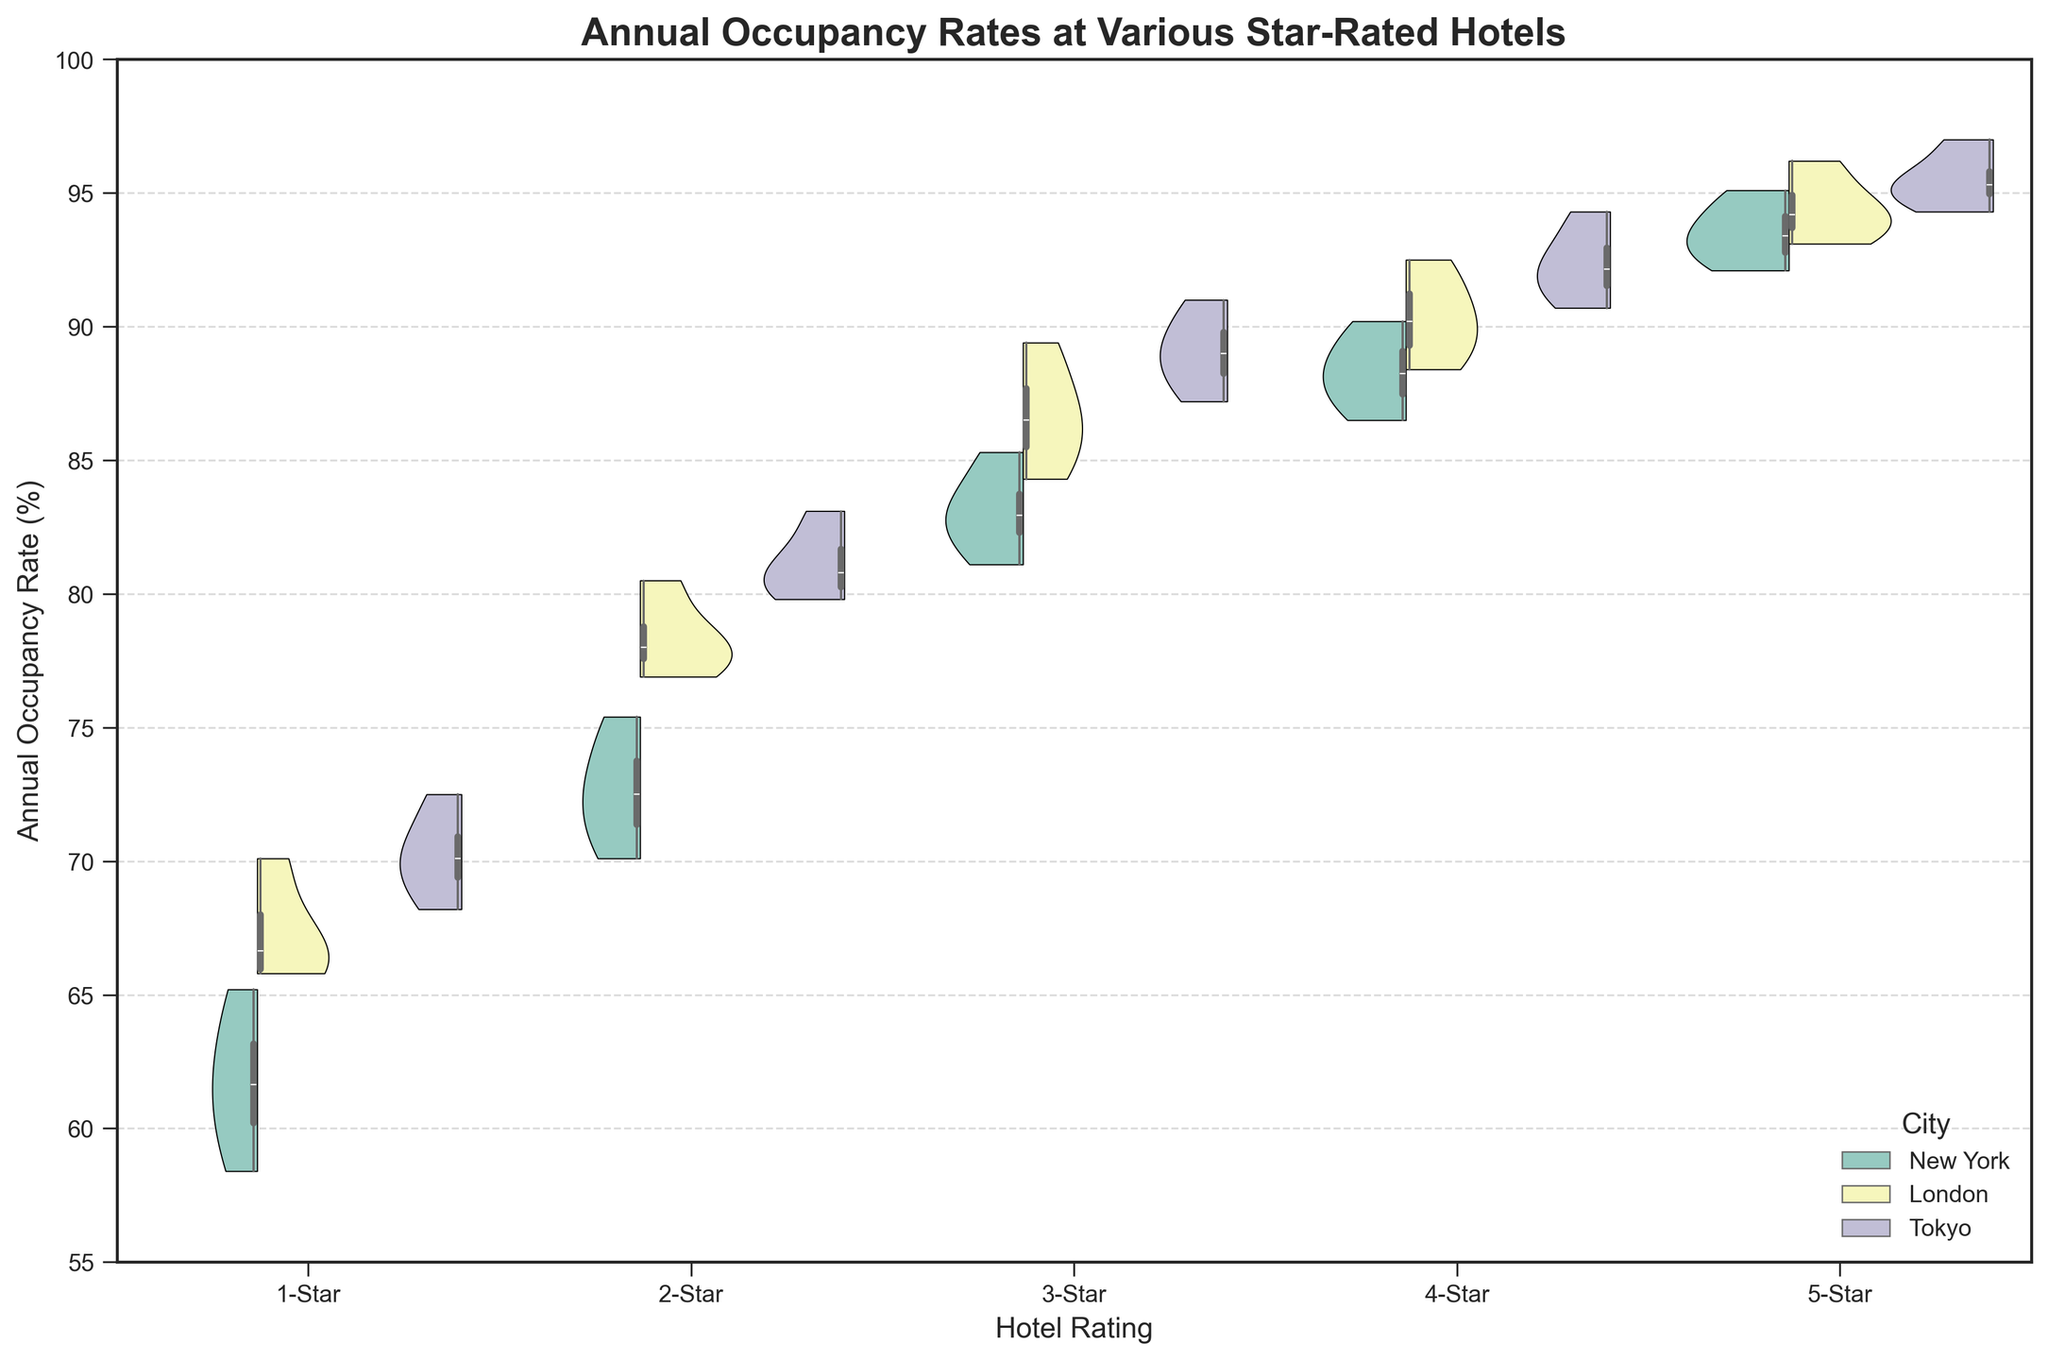What's the title of the figure? The title is displayed at the top of the figure and provides a summary of the visualized data. Looking at the figure, the title is "Annual Occupancy Rates at Various Star-Rated Hotels."
Answer: Annual Occupancy Rates at Various Star-Rated Hotels Which city has the highest median occupancy rate for 3-Star hotels? To determine this, examine the inner box plots within the violin plots for 3-Star hotels and identify which city's box plot has the highest median line. The city with the highest median occupancy rate for 3-Star hotels is Tokyo.
Answer: Tokyo Are the occupancy rates more varied in 1-Star hotels or 5-Star hotels? To assess variability, look at the width and shape of the violin plots. Wider and more spread out plots indicate greater variability. The 1-Star hotels show more spread in occupancy rates compared to 5-Star hotels.
Answer: 1-Star hotels What is the lowest observed occupancy rate for hotels in New York? Identify the smallest point in the New York box plots across all hotel ratings. The lowest point for New York is in the 1-Star category, around 58.4%.
Answer: 58.4% Do Tokyo's 5-Star hotels have a higher median occupancy rate than London's 5-Star hotels? Compare the median lines of the box plots for Tokyo and London in the 5-Star category. Tokyo's median line is higher than London's, indicating a higher median occupancy rate.
Answer: Yes How do the median occupancy rates for 4-Star hotels compare between New York and London? Examine the median lines of the box plots for New York and London in the 4-Star category. London's median is higher than New York’s.
Answer: London's is higher Which star rating shows the largest difference in median occupancy rates between New York and Tokyo? Compare the median lines of the box plots for New York and Tokyo across all star ratings. The largest difference is observed in the 2-Star category.
Answer: 2-Star For which city is the median occupancy rate of 2-Star hotels the closest to the median occupancy rate of 4-Star hotels in the same city? Compare the median lines of 2-Star and 4-Star hotels within the same city, and determine which city has the closest medians. For Tokyo, the medians of 2-Star and 4-Star hotels are closest.
Answer: Tokyo Are there any cities where the interquartile range (IQR) of occupancy rates is the same for multiple star ratings? Investigate the box plots for overlapping interquartile ranges for one city across different star ratings. Both 3-Star and 4-Star hotels in New York have similar IQRs.
Answer: New York 